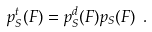<formula> <loc_0><loc_0><loc_500><loc_500>p _ { S } ^ { t } ( F ) = p _ { S } ^ { d } ( F ) p _ { S } ( F ) \ .</formula> 